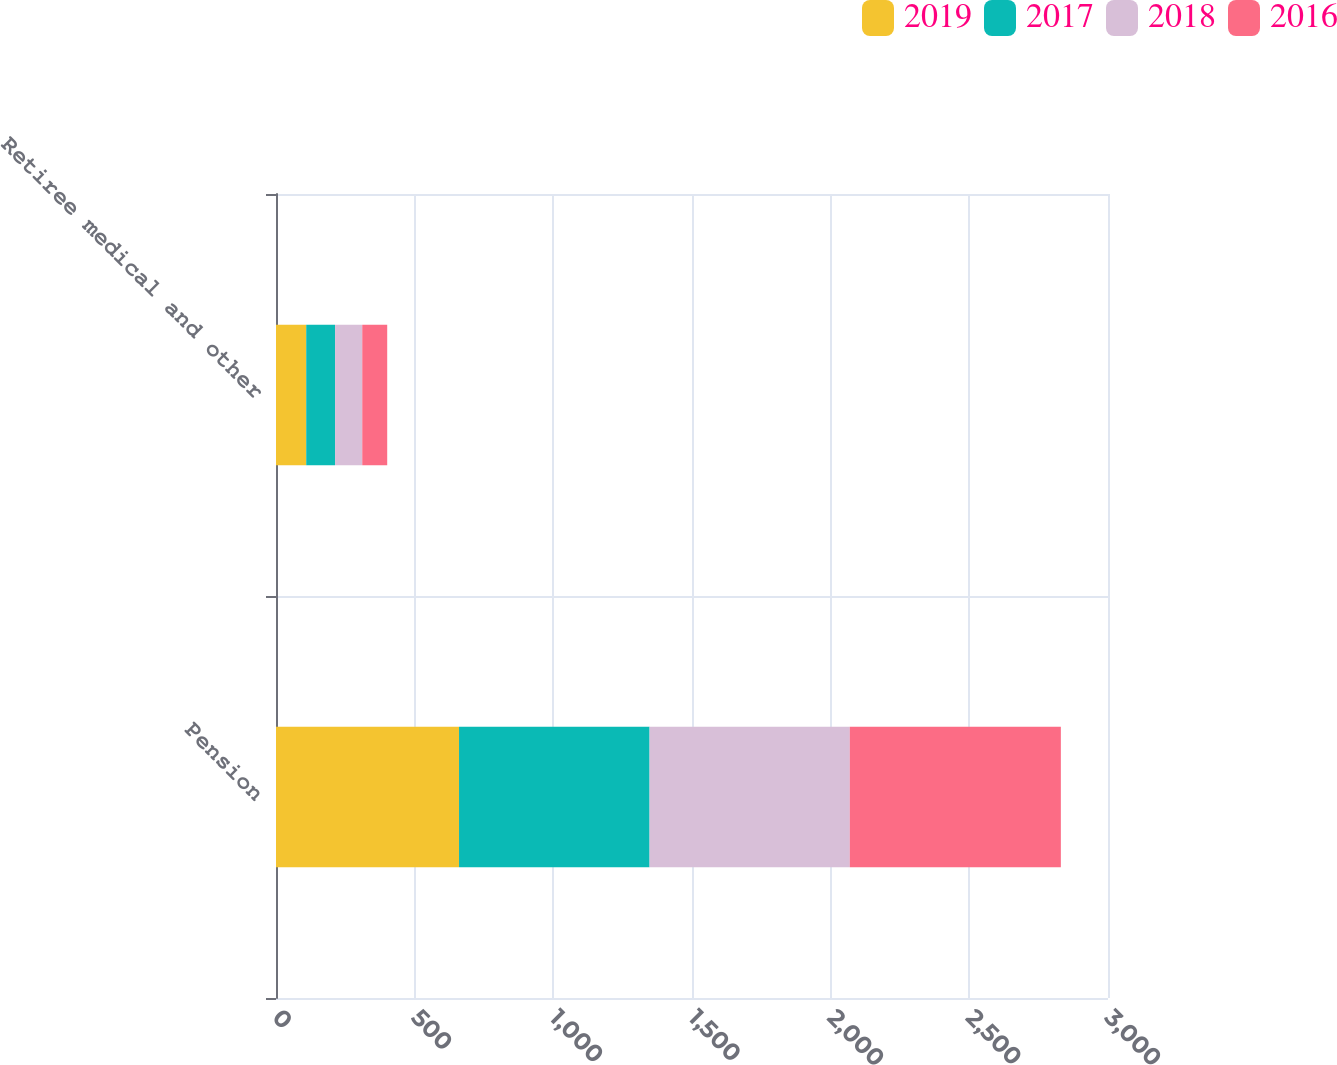Convert chart. <chart><loc_0><loc_0><loc_500><loc_500><stacked_bar_chart><ecel><fcel>Pension<fcel>Retiree medical and other<nl><fcel>2019<fcel>660<fcel>109<nl><fcel>2017<fcel>687<fcel>104<nl><fcel>2018<fcel>722<fcel>98<nl><fcel>2016<fcel>761<fcel>90<nl></chart> 